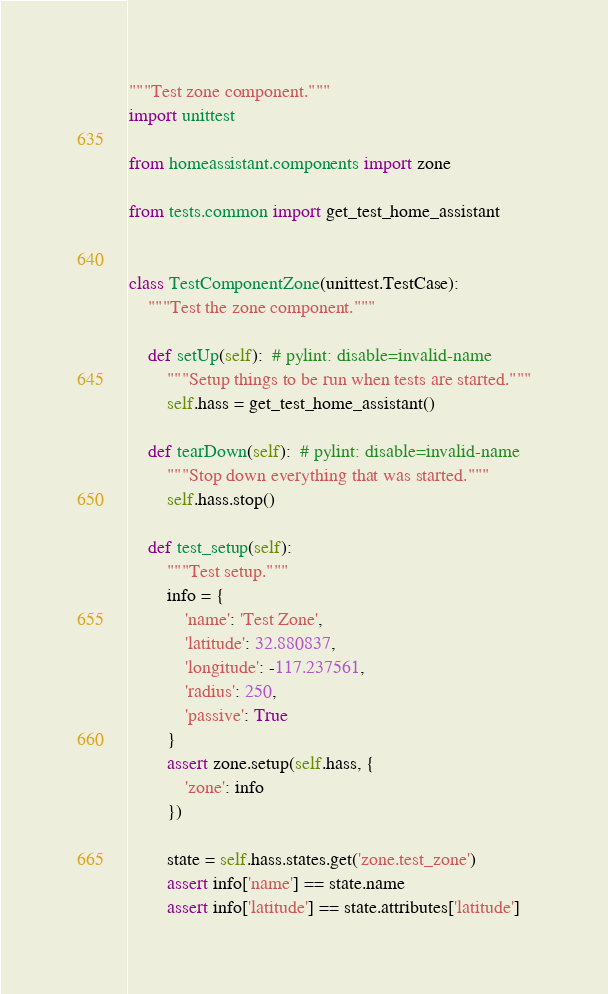<code> <loc_0><loc_0><loc_500><loc_500><_Python_>"""Test zone component."""
import unittest

from homeassistant.components import zone

from tests.common import get_test_home_assistant


class TestComponentZone(unittest.TestCase):
    """Test the zone component."""

    def setUp(self):  # pylint: disable=invalid-name
        """Setup things to be run when tests are started."""
        self.hass = get_test_home_assistant()

    def tearDown(self):  # pylint: disable=invalid-name
        """Stop down everything that was started."""
        self.hass.stop()

    def test_setup(self):
        """Test setup."""
        info = {
            'name': 'Test Zone',
            'latitude': 32.880837,
            'longitude': -117.237561,
            'radius': 250,
            'passive': True
        }
        assert zone.setup(self.hass, {
            'zone': info
        })

        state = self.hass.states.get('zone.test_zone')
        assert info['name'] == state.name
        assert info['latitude'] == state.attributes['latitude']</code> 